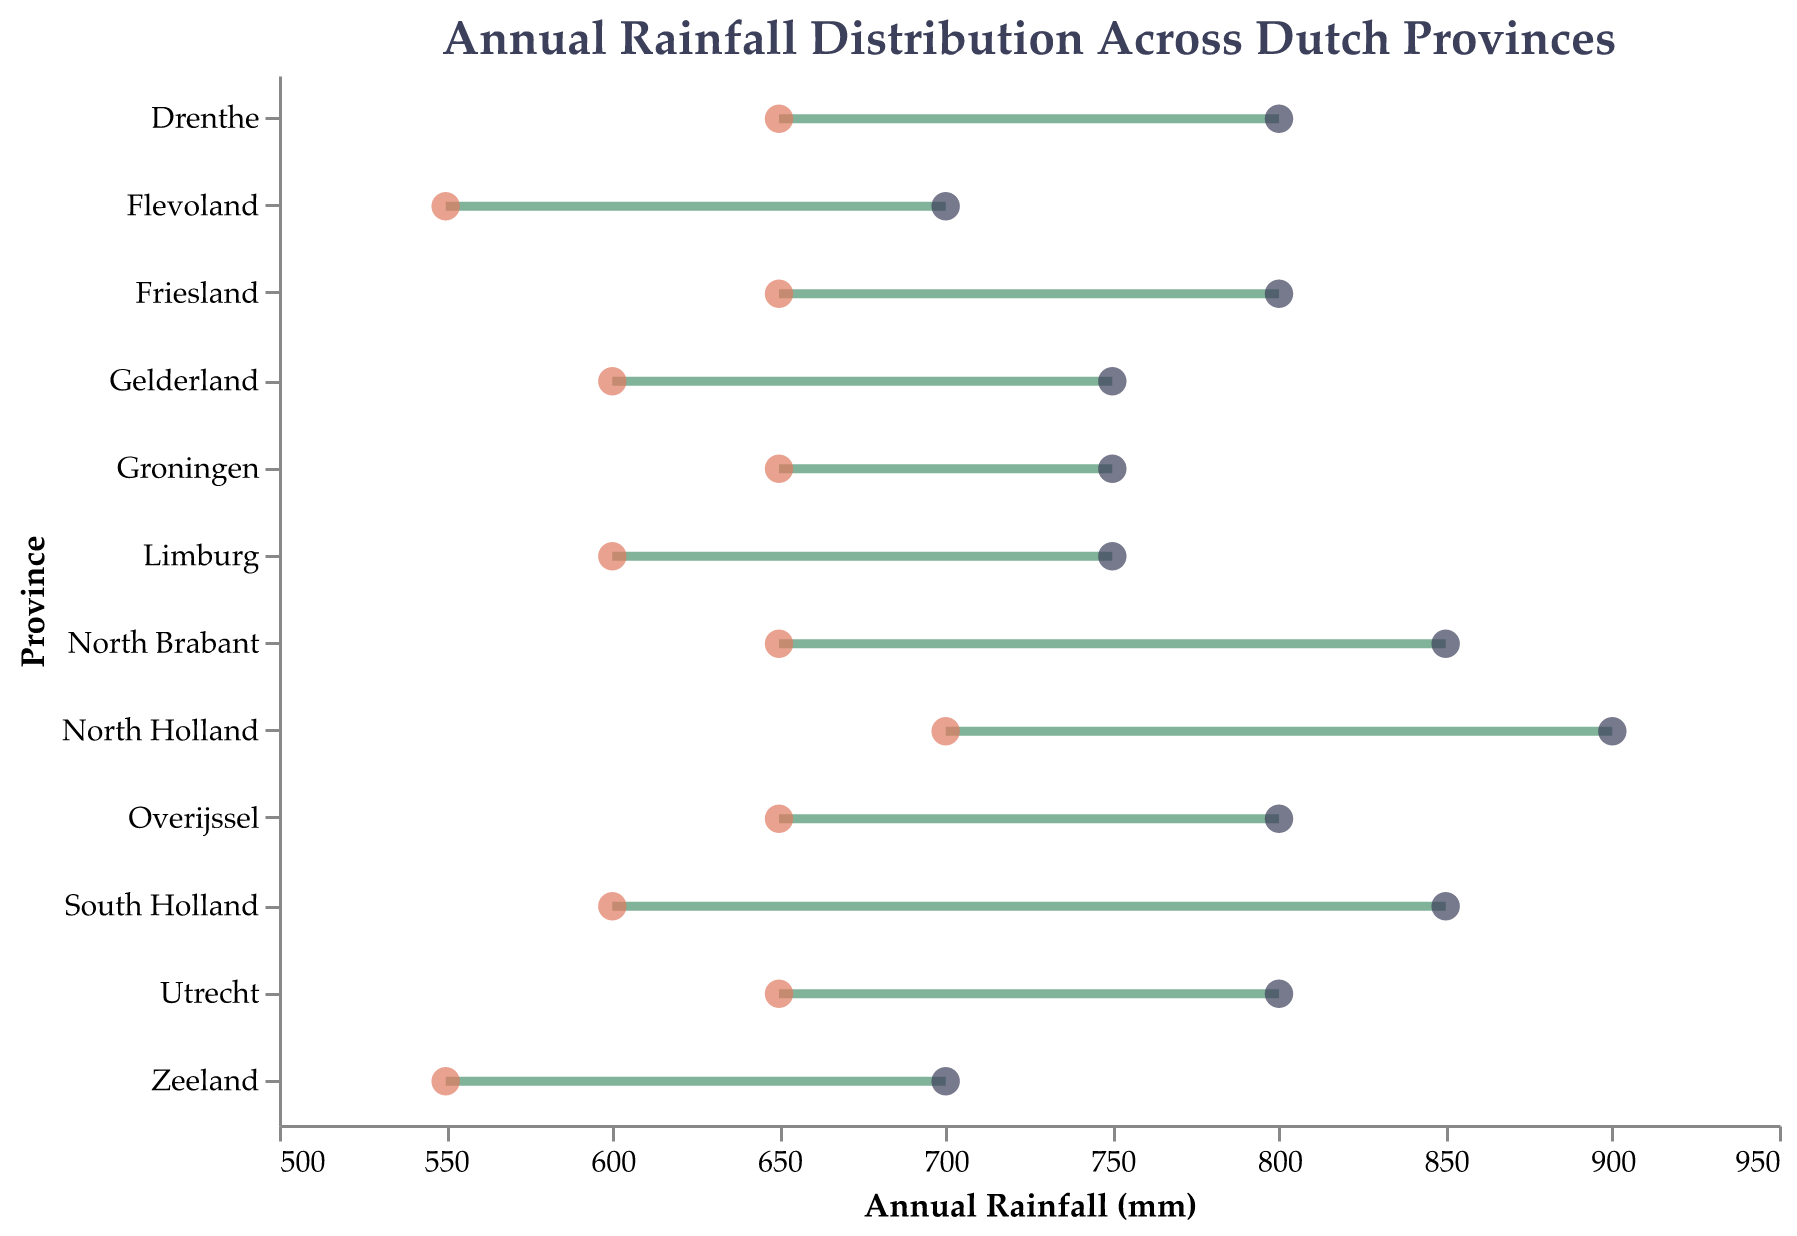Which province has the highest minimum annual rainfall? By comparing the minimum rainfall values across all provinces, North Holland has the highest minimum annual rainfall at 700 mm.
Answer: North Holland Which province has the widest range of annual rainfall? The range is calculated by subtracting the minimum rainfall from the maximum rainfall for each province. North Holland has a range of 200 mm (900 - 700). It's the widest range among all provinces.
Answer: North Holland What is the average minimum annual rainfall across all provinces? To calculate the average minimum rainfall, sum the minimum rainfall values for all provinces (700 + 600 + 650 + 600 + 550 + 650 + 650 + 550 + 600 + 650 + 650 + 650 = 7800) and divide by the number of provinces (12). The average minimum annual rainfall is 7800 / 12 = 650 mm.
Answer: 650 mm Which provinces have a maximum rainfall of 800 mm? By checking the maximum rainfall values, four provinces (Utrecht, Overijssel, Friesland, Drenthe) have a maximum rainfall of 800 mm.
Answer: Utrecht, Overijssel, Friesland, Drenthe How much more is the maximum rainfall in South Holland than in Flevoland? The difference in maximum rainfall between South Holland (850 mm) and Flevoland (700 mm) is 150 mm.
Answer: 150 mm Which province has the smallest range of annual rainfall? The range is the difference between the maximum and minimum rainfall. Groningen has the smallest range of 100 mm (750 - 650).
Answer: Groningen What is the total range of annual rainfall across all provinces? The total range is the difference between the maximum value of maximum rainfall and the minimum value of minimum rainfall. So, the total range is 900 mm (North Holland) - 550 mm (Flevoland, Zeeland) = 350 mm.
Answer: 350 mm Which province has the lowest maximum annual rainfall? By comparing the maximum rainfall values, Flevoland and Zeeland both have the lowest maximum annual rainfall at 700 mm.
Answer: Flevoland, Zeeland 